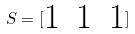<formula> <loc_0><loc_0><loc_500><loc_500>S = [ \begin{matrix} 1 & 1 & 1 \end{matrix} ]</formula> 